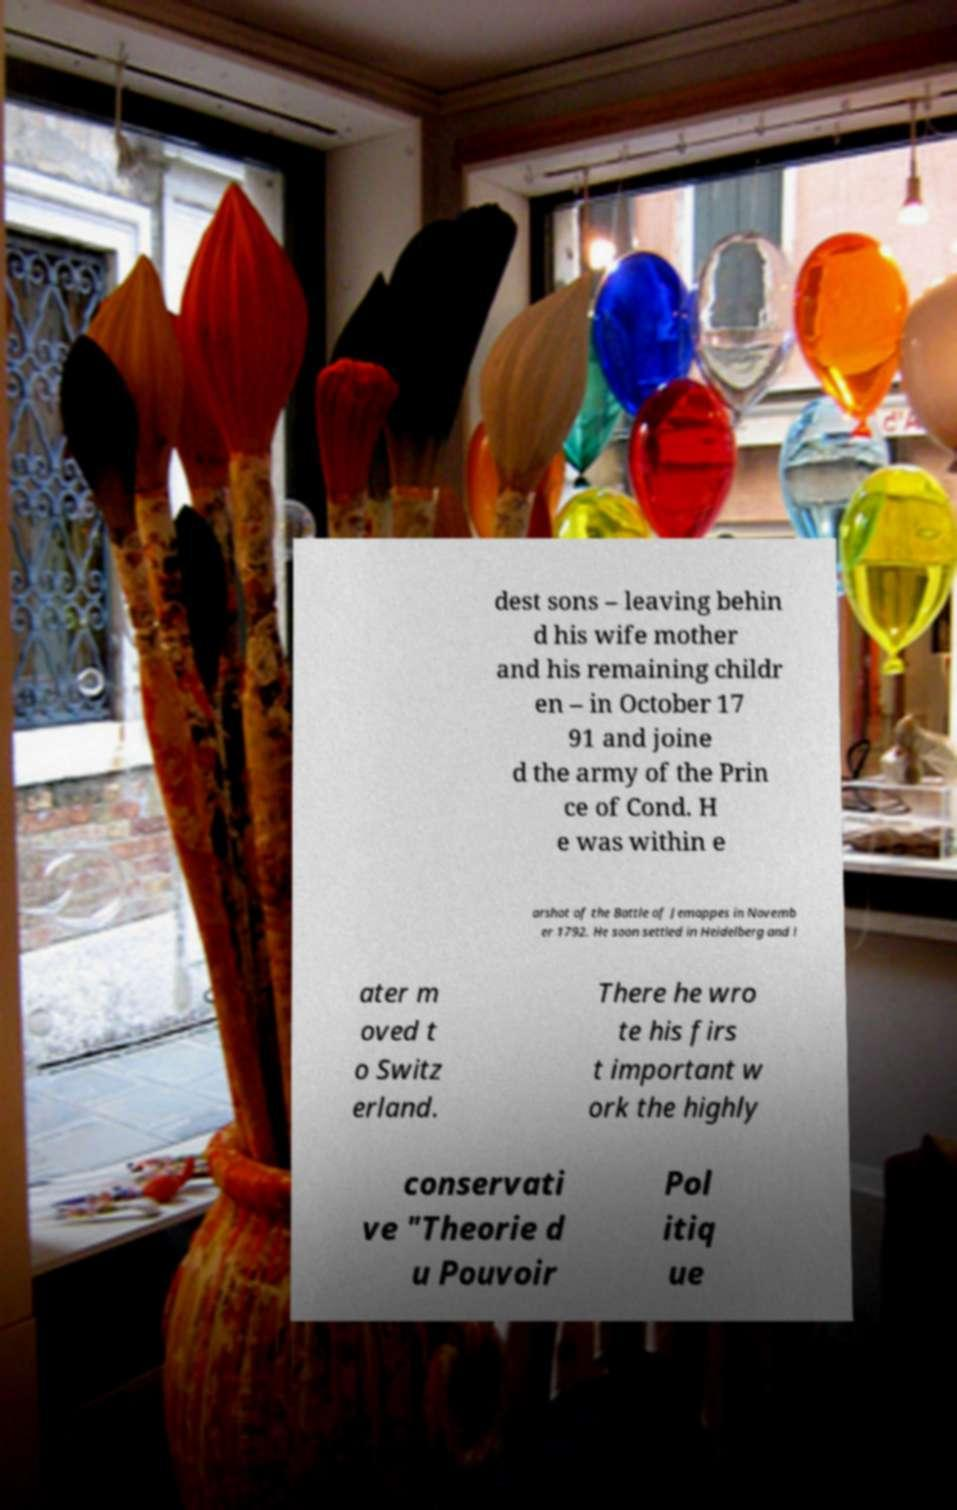There's text embedded in this image that I need extracted. Can you transcribe it verbatim? dest sons – leaving behin d his wife mother and his remaining childr en – in October 17 91 and joine d the army of the Prin ce of Cond. H e was within e arshot of the Battle of Jemappes in Novemb er 1792. He soon settled in Heidelberg and l ater m oved t o Switz erland. There he wro te his firs t important w ork the highly conservati ve "Theorie d u Pouvoir Pol itiq ue 